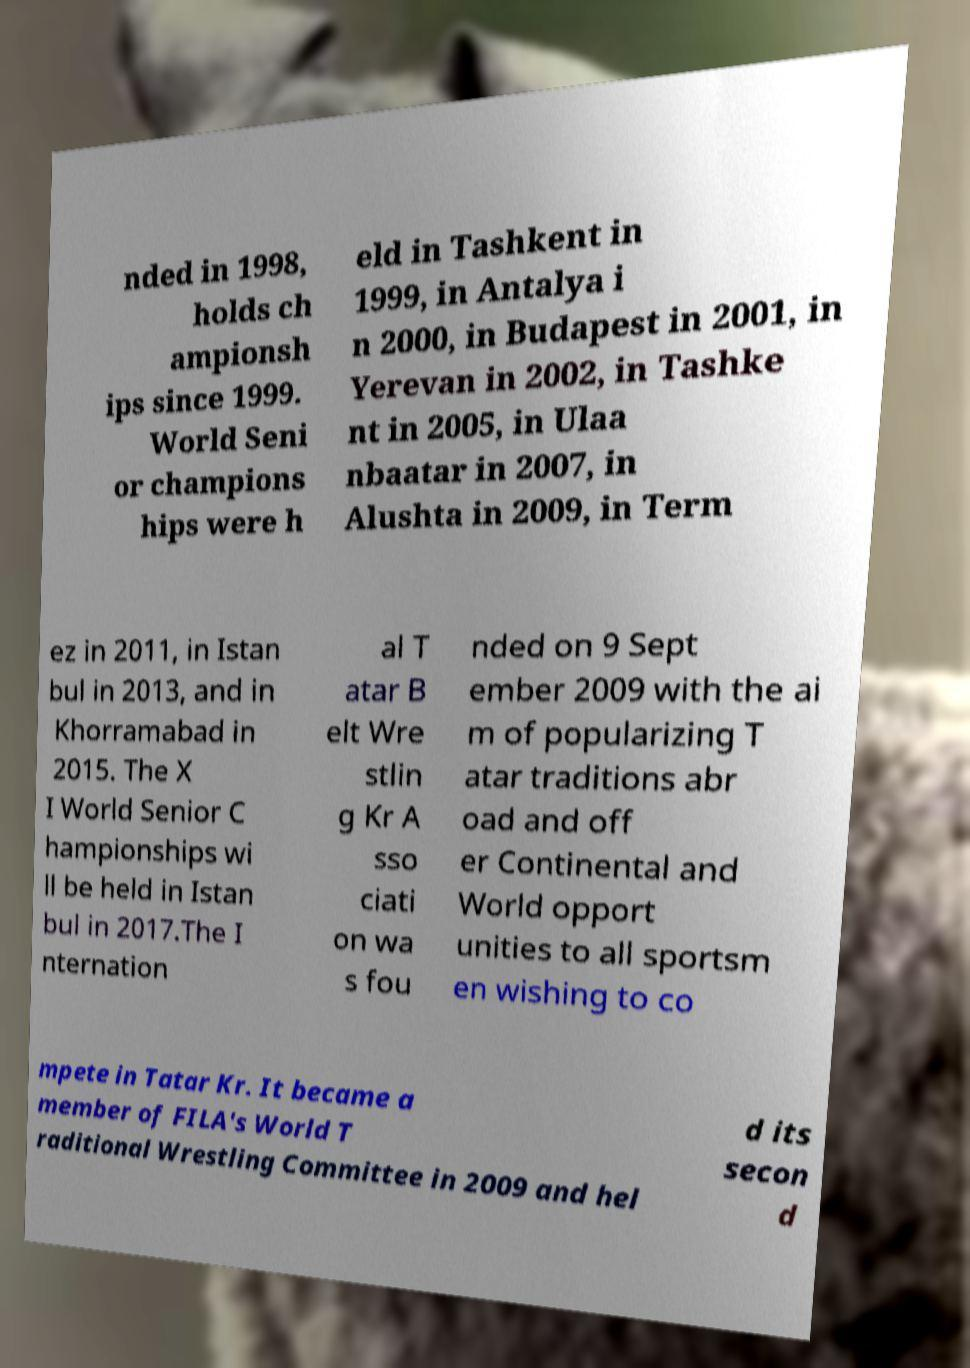Could you extract and type out the text from this image? nded in 1998, holds ch ampionsh ips since 1999. World Seni or champions hips were h eld in Tashkent in 1999, in Antalya i n 2000, in Budapest in 2001, in Yerevan in 2002, in Tashke nt in 2005, in Ulaa nbaatar in 2007, in Alushta in 2009, in Term ez in 2011, in Istan bul in 2013, and in Khorramabad in 2015. The X I World Senior C hampionships wi ll be held in Istan bul in 2017.The I nternation al T atar B elt Wre stlin g Kr A sso ciati on wa s fou nded on 9 Sept ember 2009 with the ai m of popularizing T atar traditions abr oad and off er Continental and World opport unities to all sportsm en wishing to co mpete in Tatar Kr. It became a member of FILA's World T raditional Wrestling Committee in 2009 and hel d its secon d 